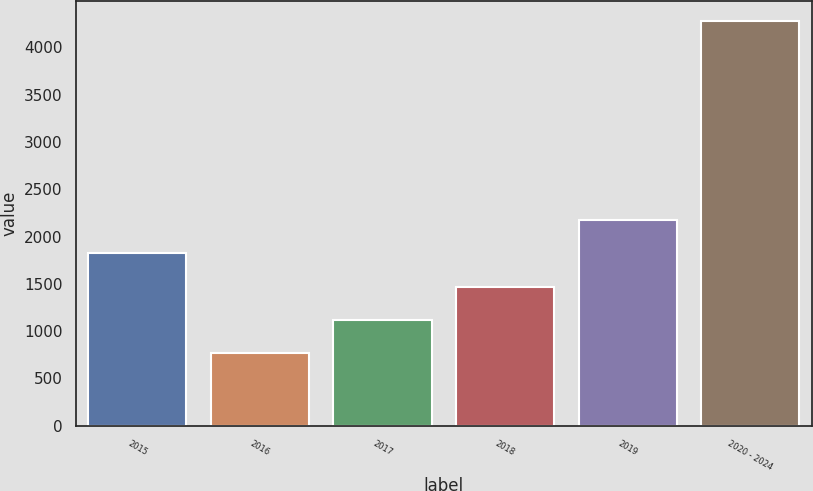Convert chart. <chart><loc_0><loc_0><loc_500><loc_500><bar_chart><fcel>2015<fcel>2016<fcel>2017<fcel>2018<fcel>2019<fcel>2020 - 2024<nl><fcel>1822<fcel>769<fcel>1120<fcel>1471<fcel>2173<fcel>4279<nl></chart> 